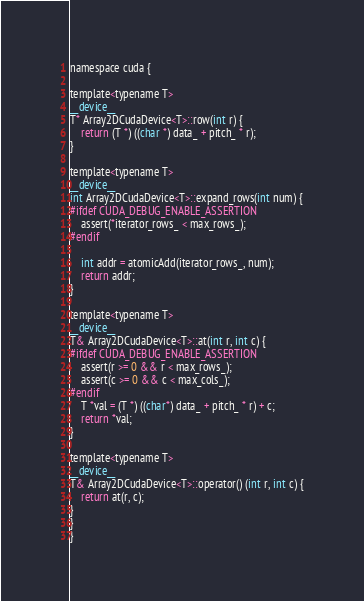Convert code to text. <code><loc_0><loc_0><loc_500><loc_500><_Cuda_>namespace cuda {

template<typename T>
__device__
T* Array2DCudaDevice<T>::row(int r) {
    return (T *) ((char *) data_ + pitch_ * r);
}

template<typename T>
__device__
int Array2DCudaDevice<T>::expand_rows(int num) {
#ifdef CUDA_DEBUG_ENABLE_ASSERTION
    assert(*iterator_rows_ < max_rows_);
#endif

    int addr = atomicAdd(iterator_rows_, num);
    return addr;
}

template<typename T>
__device__
T& Array2DCudaDevice<T>::at(int r, int c) {
#ifdef CUDA_DEBUG_ENABLE_ASSERTION
    assert(r >= 0 && r < max_rows_);
    assert(c >= 0 && c < max_cols_);
#endif
    T *val = (T *) ((char*) data_ + pitch_ * r) + c;
    return *val;
}

template<typename T>
__device__
T& Array2DCudaDevice<T>::operator() (int r, int c) {
    return at(r, c);
}
}
}</code> 